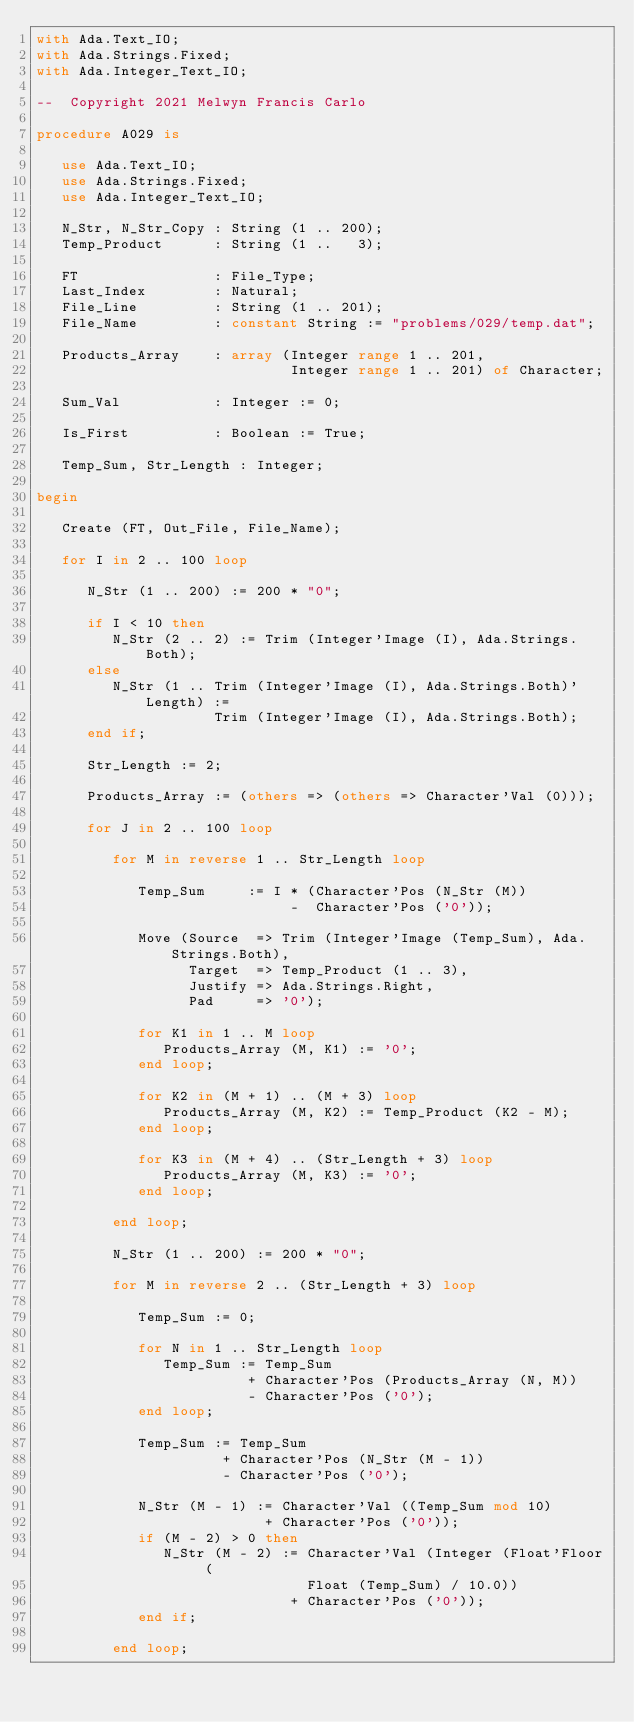Convert code to text. <code><loc_0><loc_0><loc_500><loc_500><_Ada_>with Ada.Text_IO;
with Ada.Strings.Fixed;
with Ada.Integer_Text_IO;

--  Copyright 2021 Melwyn Francis Carlo

procedure A029 is

   use Ada.Text_IO;
   use Ada.Strings.Fixed;
   use Ada.Integer_Text_IO;

   N_Str, N_Str_Copy : String (1 .. 200);
   Temp_Product      : String (1 ..   3);

   FT                : File_Type;
   Last_Index        : Natural;
   File_Line         : String (1 .. 201);
   File_Name         : constant String := "problems/029/temp.dat";

   Products_Array    : array (Integer range 1 .. 201,
                              Integer range 1 .. 201) of Character;

   Sum_Val           : Integer := 0;

   Is_First          : Boolean := True;

   Temp_Sum, Str_Length : Integer;

begin

   Create (FT, Out_File, File_Name);

   for I in 2 .. 100 loop

      N_Str (1 .. 200) := 200 * "0";

      if I < 10 then
         N_Str (2 .. 2) := Trim (Integer'Image (I), Ada.Strings.Both);
      else
         N_Str (1 .. Trim (Integer'Image (I), Ada.Strings.Both)'Length) :=
                     Trim (Integer'Image (I), Ada.Strings.Both);
      end if;

      Str_Length := 2;

      Products_Array := (others => (others => Character'Val (0)));

      for J in 2 .. 100 loop

         for M in reverse 1 .. Str_Length loop

            Temp_Sum     := I * (Character'Pos (N_Str (M))
                              -  Character'Pos ('0'));

            Move (Source  => Trim (Integer'Image (Temp_Sum), Ada.Strings.Both),
                  Target  => Temp_Product (1 .. 3),
                  Justify => Ada.Strings.Right,
                  Pad     => '0');

            for K1 in 1 .. M loop
               Products_Array (M, K1) := '0';
            end loop;

            for K2 in (M + 1) .. (M + 3) loop
               Products_Array (M, K2) := Temp_Product (K2 - M);
            end loop;

            for K3 in (M + 4) .. (Str_Length + 3) loop
               Products_Array (M, K3) := '0';
            end loop;

         end loop;

         N_Str (1 .. 200) := 200 * "0";

         for M in reverse 2 .. (Str_Length + 3) loop

            Temp_Sum := 0;

            for N in 1 .. Str_Length loop
               Temp_Sum := Temp_Sum
                         + Character'Pos (Products_Array (N, M))
                         - Character'Pos ('0');
            end loop;

            Temp_Sum := Temp_Sum
                      + Character'Pos (N_Str (M - 1))
                      - Character'Pos ('0');

            N_Str (M - 1) := Character'Val ((Temp_Sum mod 10)
                           + Character'Pos ('0'));
            if (M - 2) > 0 then
               N_Str (M - 2) := Character'Val (Integer (Float'Floor (
                                Float (Temp_Sum) / 10.0))
                              + Character'Pos ('0'));
            end if;

         end loop;
</code> 